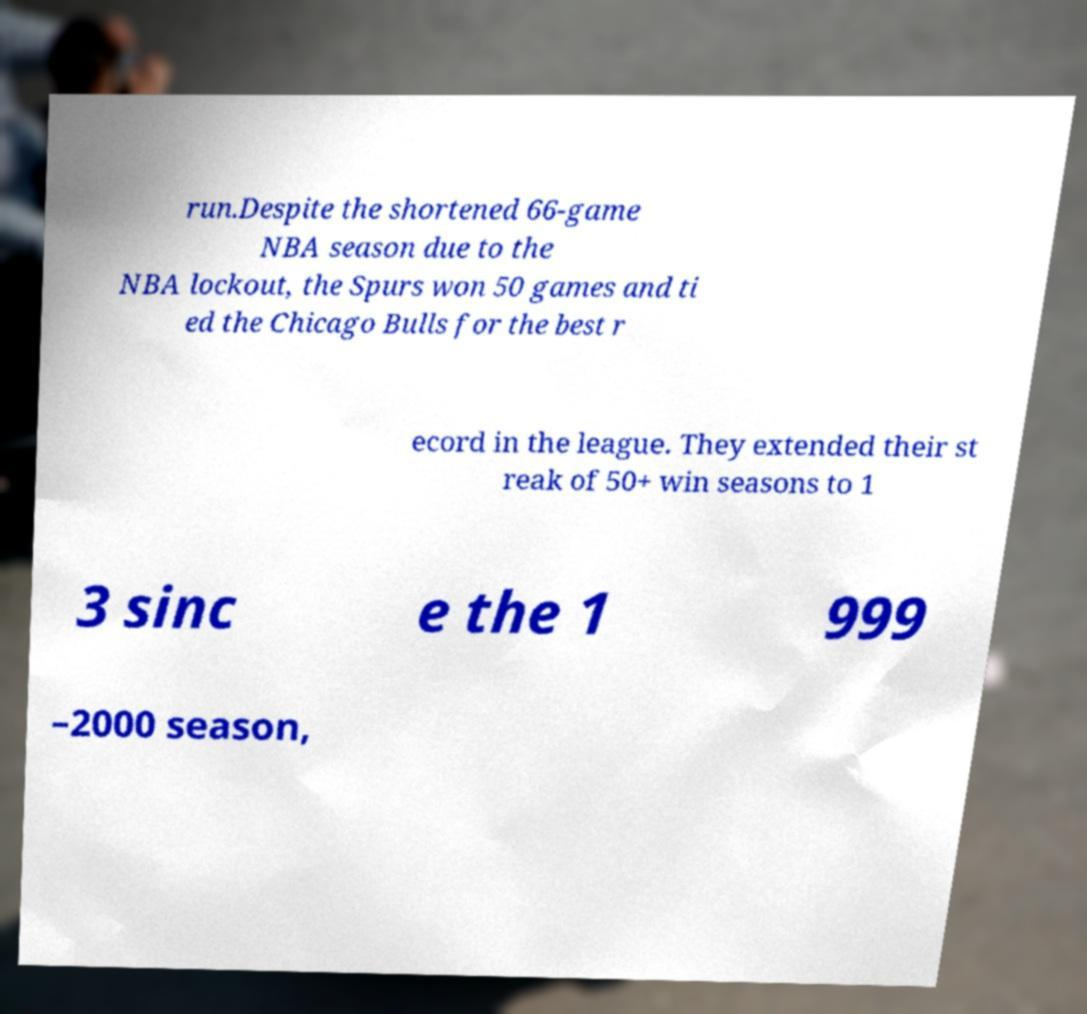For documentation purposes, I need the text within this image transcribed. Could you provide that? run.Despite the shortened 66-game NBA season due to the NBA lockout, the Spurs won 50 games and ti ed the Chicago Bulls for the best r ecord in the league. They extended their st reak of 50+ win seasons to 1 3 sinc e the 1 999 –2000 season, 